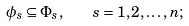Convert formula to latex. <formula><loc_0><loc_0><loc_500><loc_500>\phi _ { s } \subseteq \Phi _ { s } , \quad s = 1 , 2 , \dots , n ;</formula> 